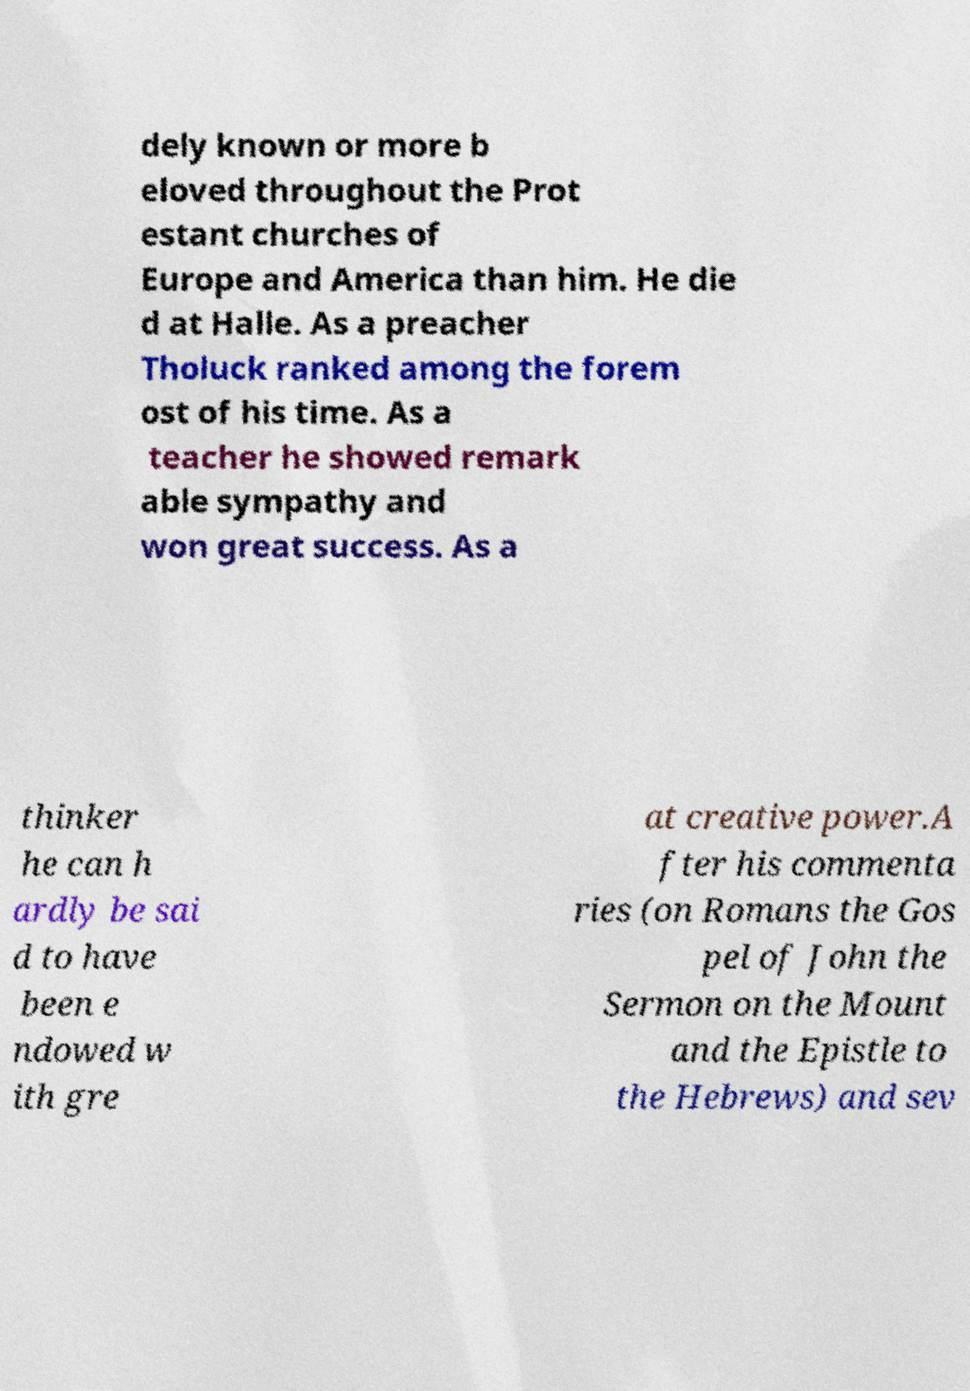Please identify and transcribe the text found in this image. dely known or more b eloved throughout the Prot estant churches of Europe and America than him. He die d at Halle. As a preacher Tholuck ranked among the forem ost of his time. As a teacher he showed remark able sympathy and won great success. As a thinker he can h ardly be sai d to have been e ndowed w ith gre at creative power.A fter his commenta ries (on Romans the Gos pel of John the Sermon on the Mount and the Epistle to the Hebrews) and sev 